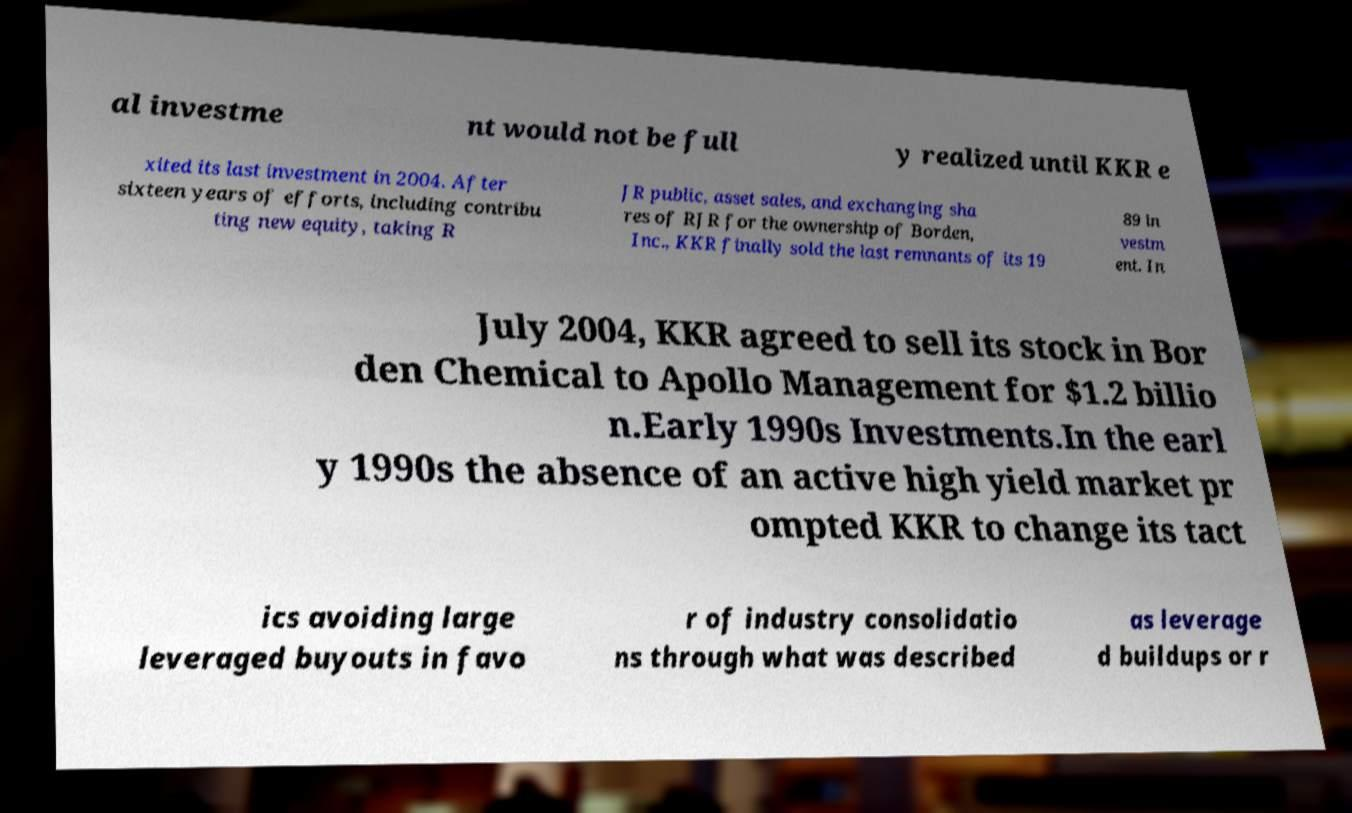What messages or text are displayed in this image? I need them in a readable, typed format. al investme nt would not be full y realized until KKR e xited its last investment in 2004. After sixteen years of efforts, including contribu ting new equity, taking R JR public, asset sales, and exchanging sha res of RJR for the ownership of Borden, Inc., KKR finally sold the last remnants of its 19 89 in vestm ent. In July 2004, KKR agreed to sell its stock in Bor den Chemical to Apollo Management for $1.2 billio n.Early 1990s Investments.In the earl y 1990s the absence of an active high yield market pr ompted KKR to change its tact ics avoiding large leveraged buyouts in favo r of industry consolidatio ns through what was described as leverage d buildups or r 